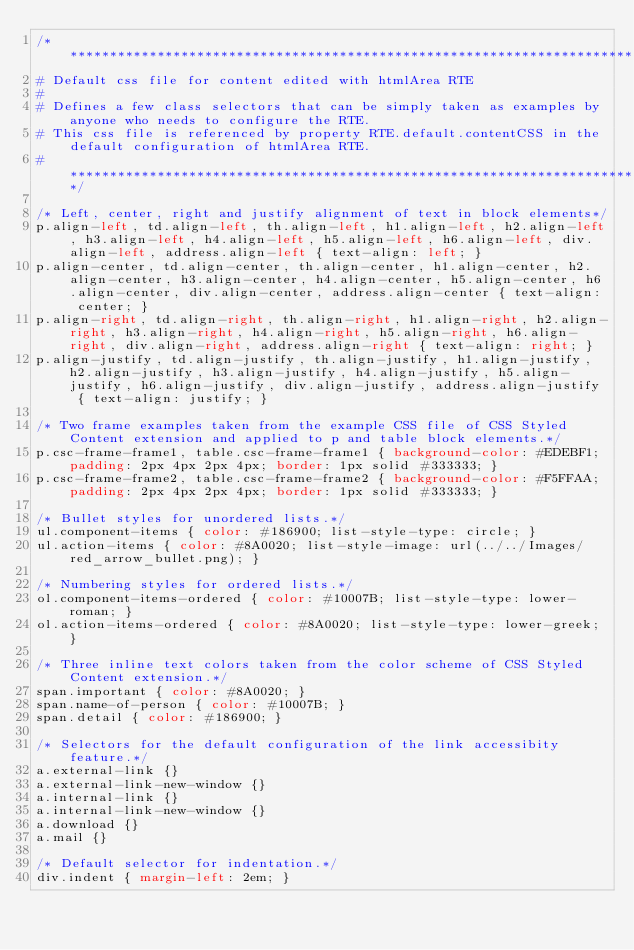Convert code to text. <code><loc_0><loc_0><loc_500><loc_500><_CSS_>/****************************************************************************************
# Default css file for content edited with htmlArea RTE
#
# Defines a few class selectors that can be simply taken as examples by anyone who needs to configure the RTE.
# This css file is referenced by property RTE.default.contentCSS in the default configuration of htmlArea RTE.
# ***************************************************************************************/

/* Left, center, right and justify alignment of text in block elements*/
p.align-left, td.align-left, th.align-left, h1.align-left, h2.align-left, h3.align-left, h4.align-left, h5.align-left, h6.align-left, div.align-left, address.align-left { text-align: left; }
p.align-center, td.align-center, th.align-center, h1.align-center, h2.align-center, h3.align-center, h4.align-center, h5.align-center, h6.align-center, div.align-center, address.align-center { text-align: center; }
p.align-right, td.align-right, th.align-right, h1.align-right, h2.align-right, h3.align-right, h4.align-right, h5.align-right, h6.align-right, div.align-right, address.align-right { text-align: right; }
p.align-justify, td.align-justify, th.align-justify, h1.align-justify, h2.align-justify, h3.align-justify, h4.align-justify, h5.align-justify, h6.align-justify, div.align-justify, address.align-justify { text-align: justify; }

/* Two frame examples taken from the example CSS file of CSS Styled Content extension and applied to p and table block elements.*/
p.csc-frame-frame1, table.csc-frame-frame1 { background-color: #EDEBF1; padding: 2px 4px 2px 4px; border: 1px solid #333333; }
p.csc-frame-frame2, table.csc-frame-frame2 { background-color: #F5FFAA; padding: 2px 4px 2px 4px; border: 1px solid #333333; }

/* Bullet styles for unordered lists.*/
ul.component-items { color: #186900; list-style-type: circle; }
ul.action-items { color: #8A0020; list-style-image: url(../../Images/red_arrow_bullet.png); }

/* Numbering styles for ordered lists.*/
ol.component-items-ordered { color: #10007B; list-style-type: lower-roman; }
ol.action-items-ordered { color: #8A0020; list-style-type: lower-greek; }

/* Three inline text colors taken from the color scheme of CSS Styled Content extension.*/
span.important { color: #8A0020; }
span.name-of-person { color: #10007B; }
span.detail { color: #186900; }

/* Selectors for the default configuration of the link accessibity feature.*/
a.external-link {}
a.external-link-new-window {}
a.internal-link {}
a.internal-link-new-window {}
a.download {}
a.mail {}

/* Default selector for indentation.*/
div.indent { margin-left: 2em; }
</code> 